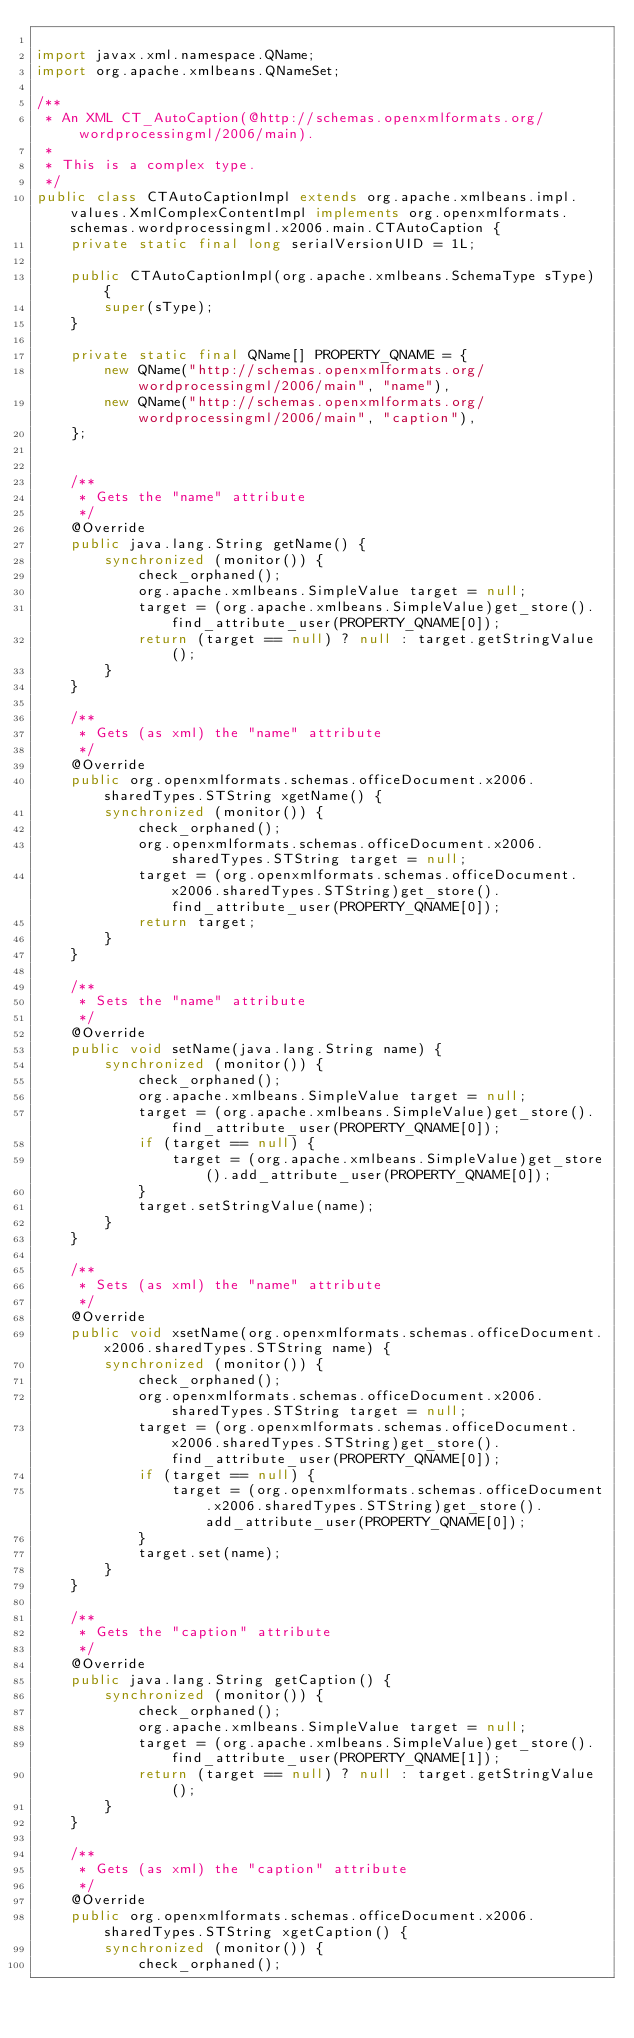<code> <loc_0><loc_0><loc_500><loc_500><_Java_>
import javax.xml.namespace.QName;
import org.apache.xmlbeans.QNameSet;

/**
 * An XML CT_AutoCaption(@http://schemas.openxmlformats.org/wordprocessingml/2006/main).
 *
 * This is a complex type.
 */
public class CTAutoCaptionImpl extends org.apache.xmlbeans.impl.values.XmlComplexContentImpl implements org.openxmlformats.schemas.wordprocessingml.x2006.main.CTAutoCaption {
    private static final long serialVersionUID = 1L;

    public CTAutoCaptionImpl(org.apache.xmlbeans.SchemaType sType) {
        super(sType);
    }

    private static final QName[] PROPERTY_QNAME = {
        new QName("http://schemas.openxmlformats.org/wordprocessingml/2006/main", "name"),
        new QName("http://schemas.openxmlformats.org/wordprocessingml/2006/main", "caption"),
    };


    /**
     * Gets the "name" attribute
     */
    @Override
    public java.lang.String getName() {
        synchronized (monitor()) {
            check_orphaned();
            org.apache.xmlbeans.SimpleValue target = null;
            target = (org.apache.xmlbeans.SimpleValue)get_store().find_attribute_user(PROPERTY_QNAME[0]);
            return (target == null) ? null : target.getStringValue();
        }
    }

    /**
     * Gets (as xml) the "name" attribute
     */
    @Override
    public org.openxmlformats.schemas.officeDocument.x2006.sharedTypes.STString xgetName() {
        synchronized (monitor()) {
            check_orphaned();
            org.openxmlformats.schemas.officeDocument.x2006.sharedTypes.STString target = null;
            target = (org.openxmlformats.schemas.officeDocument.x2006.sharedTypes.STString)get_store().find_attribute_user(PROPERTY_QNAME[0]);
            return target;
        }
    }

    /**
     * Sets the "name" attribute
     */
    @Override
    public void setName(java.lang.String name) {
        synchronized (monitor()) {
            check_orphaned();
            org.apache.xmlbeans.SimpleValue target = null;
            target = (org.apache.xmlbeans.SimpleValue)get_store().find_attribute_user(PROPERTY_QNAME[0]);
            if (target == null) {
                target = (org.apache.xmlbeans.SimpleValue)get_store().add_attribute_user(PROPERTY_QNAME[0]);
            }
            target.setStringValue(name);
        }
    }

    /**
     * Sets (as xml) the "name" attribute
     */
    @Override
    public void xsetName(org.openxmlformats.schemas.officeDocument.x2006.sharedTypes.STString name) {
        synchronized (monitor()) {
            check_orphaned();
            org.openxmlformats.schemas.officeDocument.x2006.sharedTypes.STString target = null;
            target = (org.openxmlformats.schemas.officeDocument.x2006.sharedTypes.STString)get_store().find_attribute_user(PROPERTY_QNAME[0]);
            if (target == null) {
                target = (org.openxmlformats.schemas.officeDocument.x2006.sharedTypes.STString)get_store().add_attribute_user(PROPERTY_QNAME[0]);
            }
            target.set(name);
        }
    }

    /**
     * Gets the "caption" attribute
     */
    @Override
    public java.lang.String getCaption() {
        synchronized (monitor()) {
            check_orphaned();
            org.apache.xmlbeans.SimpleValue target = null;
            target = (org.apache.xmlbeans.SimpleValue)get_store().find_attribute_user(PROPERTY_QNAME[1]);
            return (target == null) ? null : target.getStringValue();
        }
    }

    /**
     * Gets (as xml) the "caption" attribute
     */
    @Override
    public org.openxmlformats.schemas.officeDocument.x2006.sharedTypes.STString xgetCaption() {
        synchronized (monitor()) {
            check_orphaned();</code> 